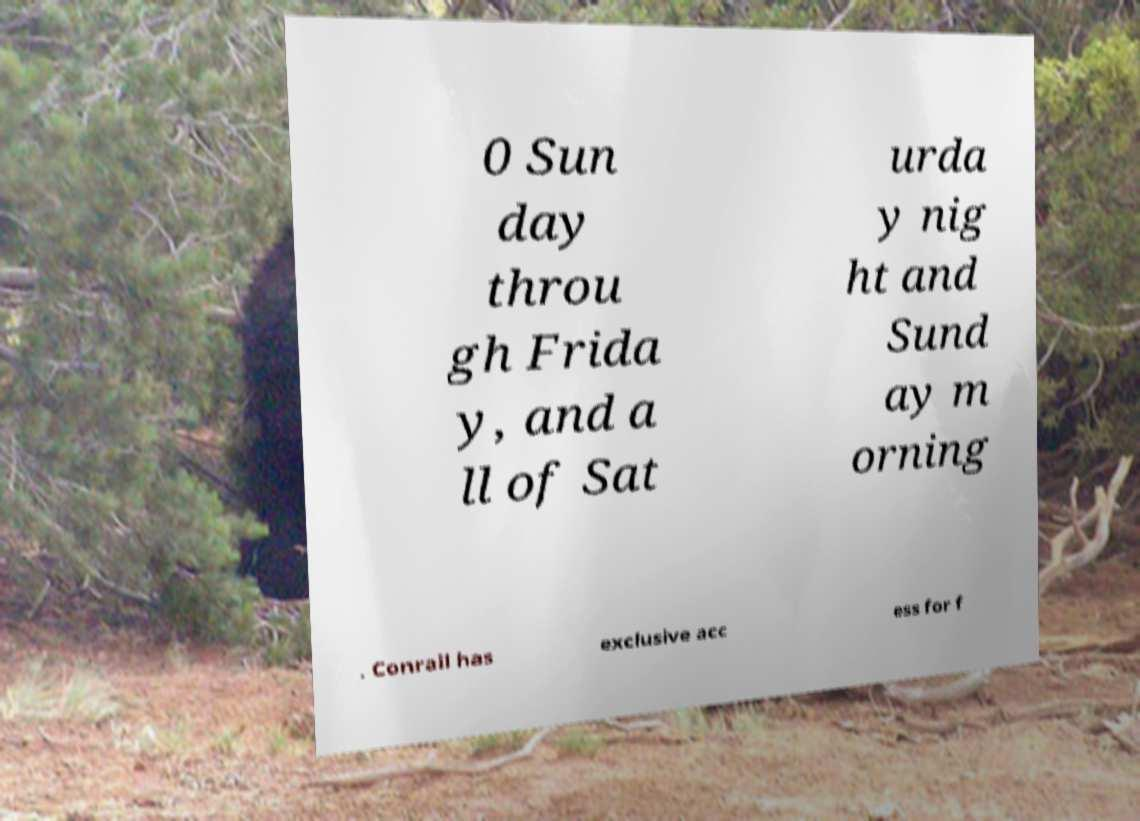I need the written content from this picture converted into text. Can you do that? 0 Sun day throu gh Frida y, and a ll of Sat urda y nig ht and Sund ay m orning . Conrail has exclusive acc ess for f 